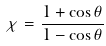Convert formula to latex. <formula><loc_0><loc_0><loc_500><loc_500>\chi = \frac { 1 + \cos \theta } { 1 - \cos \theta }</formula> 